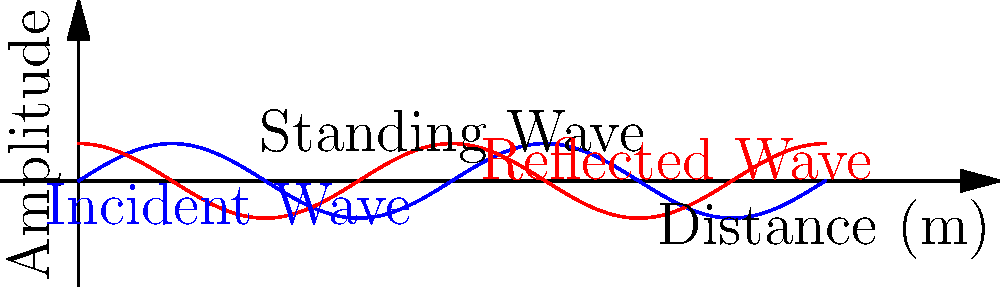In the acoustic design of a worship space, standing waves can significantly impact sound quality. The graph shows an incident wave (blue) and its reflection (red) in a rectangular sanctuary. If the sanctuary is 10 meters long and the wavelength of the sound is 5 meters, at which frequencies will standing waves occur, and how might this affect the clarity of spoken words during a sermon? To determine the frequencies at which standing waves occur and understand their impact on speech clarity, we need to follow these steps:

1. Identify the relationship between wavelength and frequency:
   $$c = f\lambda$$
   where $c$ is the speed of sound (approximately 343 m/s at room temperature), $f$ is frequency, and $\lambda$ is wavelength.

2. Calculate the fundamental frequency:
   Given $\lambda = 5$ m, we can find $f$:
   $$f = \frac{c}{\lambda} = \frac{343 \text{ m/s}}{5 \text{ m}} = 68.6 \text{ Hz}$$

3. Determine the harmonic frequencies:
   Standing waves occur at the fundamental frequency and its integer multiples:
   $$f_n = n \cdot f_1$$
   where $n = 1, 2, 3, ...$
   So, standing waves will occur at 68.6 Hz, 137.2 Hz, 205.8 Hz, and so on.

4. Consider the impact on speech clarity:
   - The fundamental frequency (68.6 Hz) is below the typical range of human speech (100-8000 Hz).
   - However, higher harmonics fall within the speech range and can cause:
     a) Resonance at certain frequencies, amplifying some speech sounds.
     b) Cancellation at other frequencies, reducing clarity of certain sounds.
   - This can lead to uneven sound distribution and reduced intelligibility, especially for consonants which are crucial for speech understanding.

5. Potential solutions:
   - Use of sound-absorbing materials to reduce reflections.
   - Implementation of diffusers to scatter sound waves.
   - Careful placement of sound sources and listeners to avoid nodes and antinodes.
   - Consider electronic sound reinforcement systems with equalization to compensate for room acoustics.
Answer: Standing waves occur at 68.6 Hz and its multiples, potentially reducing speech clarity by causing uneven frequency response within the speech range. 